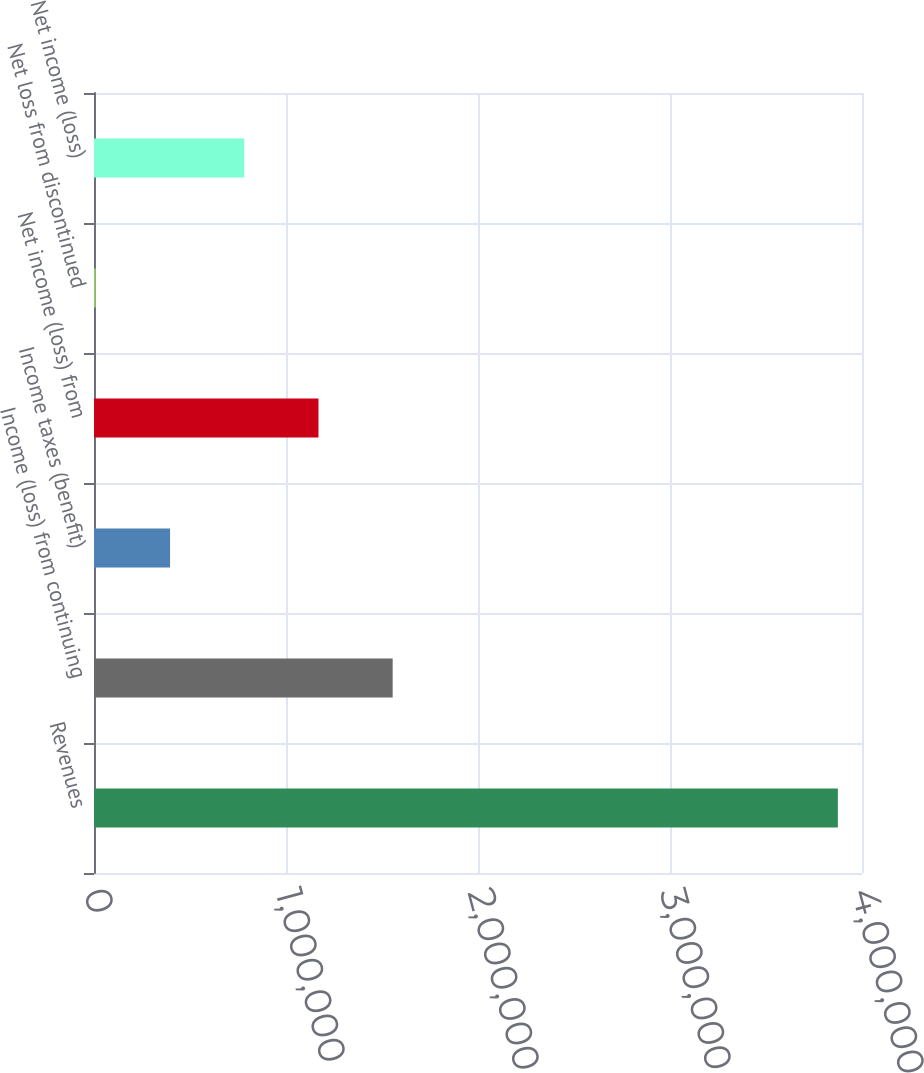Convert chart. <chart><loc_0><loc_0><loc_500><loc_500><bar_chart><fcel>Revenues<fcel>Income (loss) from continuing<fcel>Income taxes (benefit)<fcel>Net income (loss) from<fcel>Net loss from discontinued<fcel>Net income (loss)<nl><fcel>3.87433e+06<fcel>1.55556e+06<fcel>396167<fcel>1.16909e+06<fcel>9704<fcel>782630<nl></chart> 